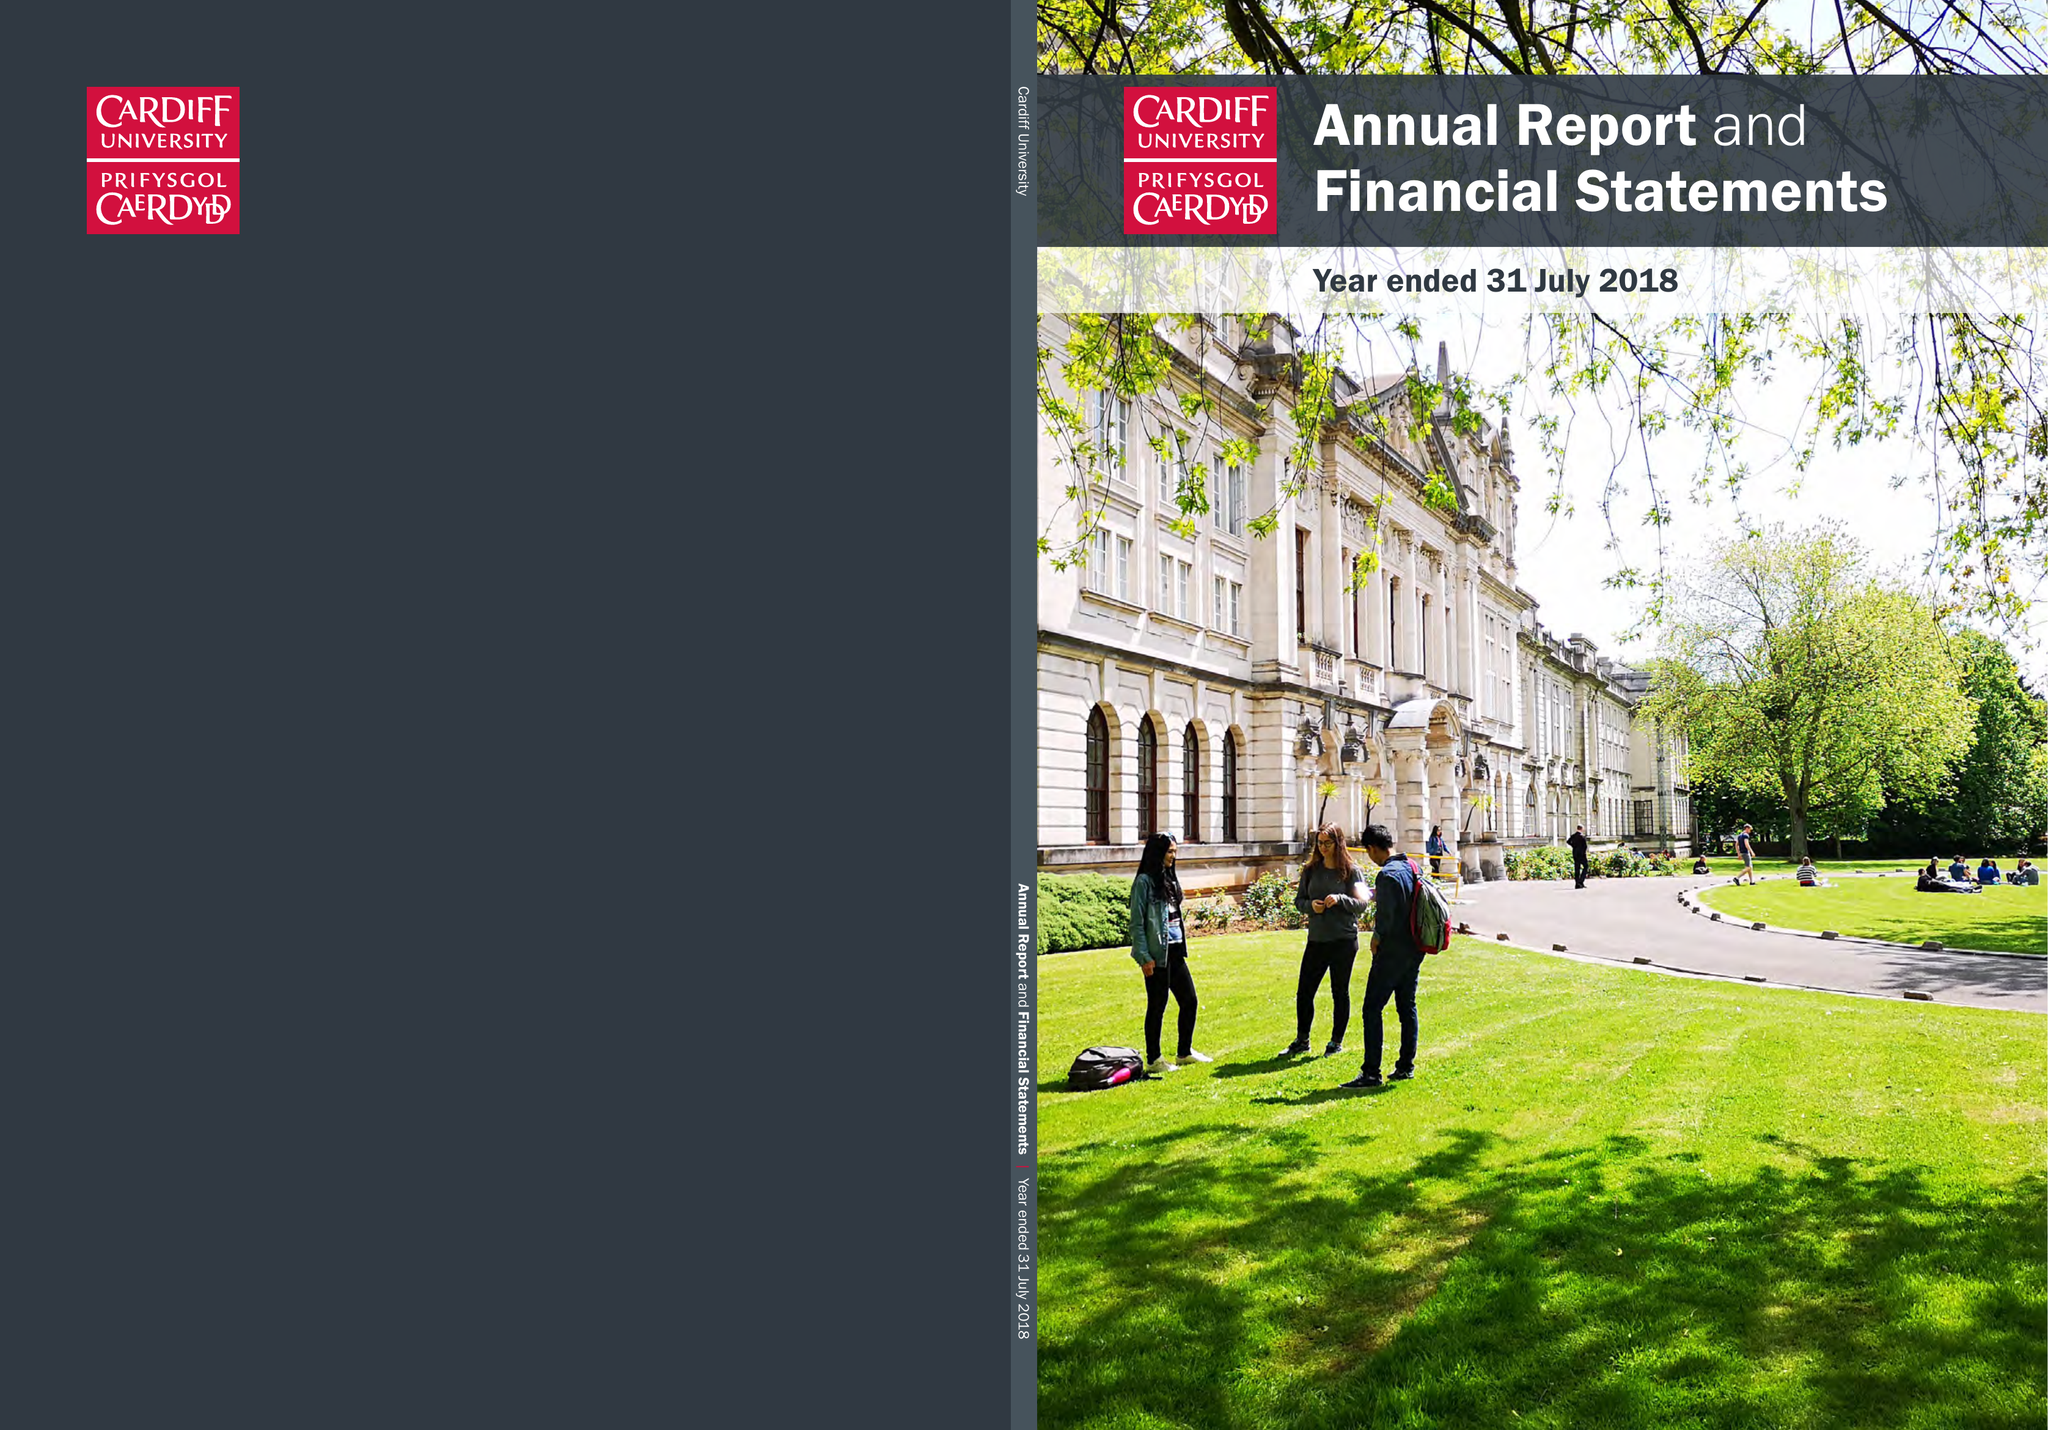What is the value for the address__street_line?
Answer the question using a single word or phrase. GREYFRIARS ROAD 